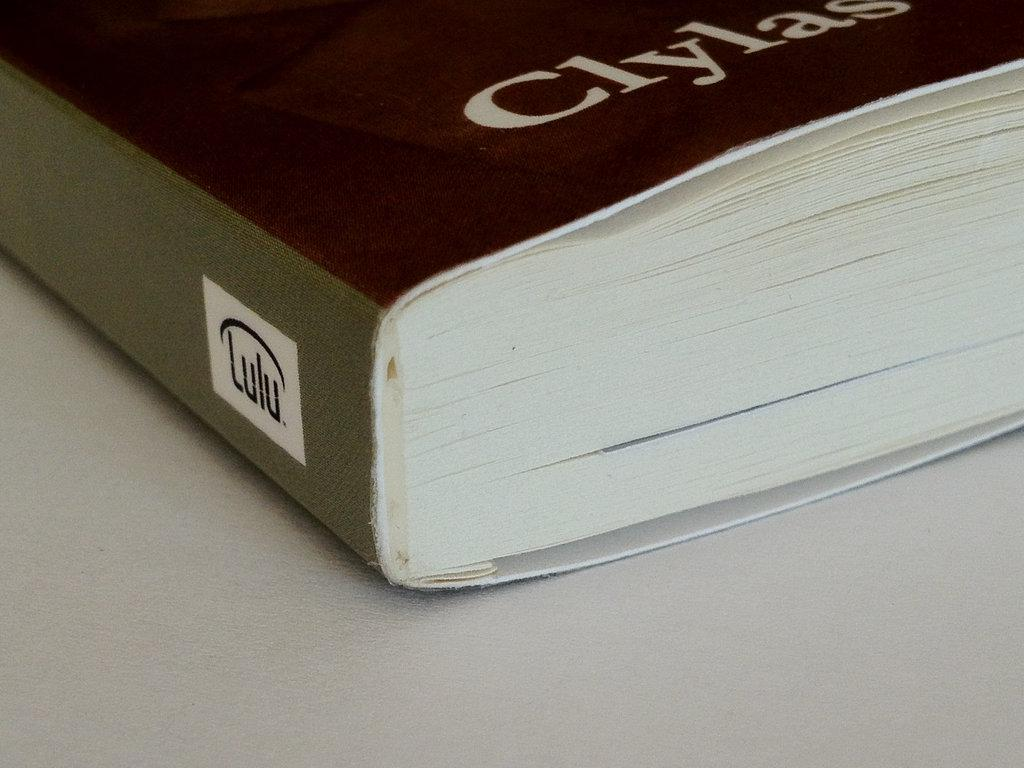Provide a one-sentence caption for the provided image. A black book with Clylas written on the cover. 